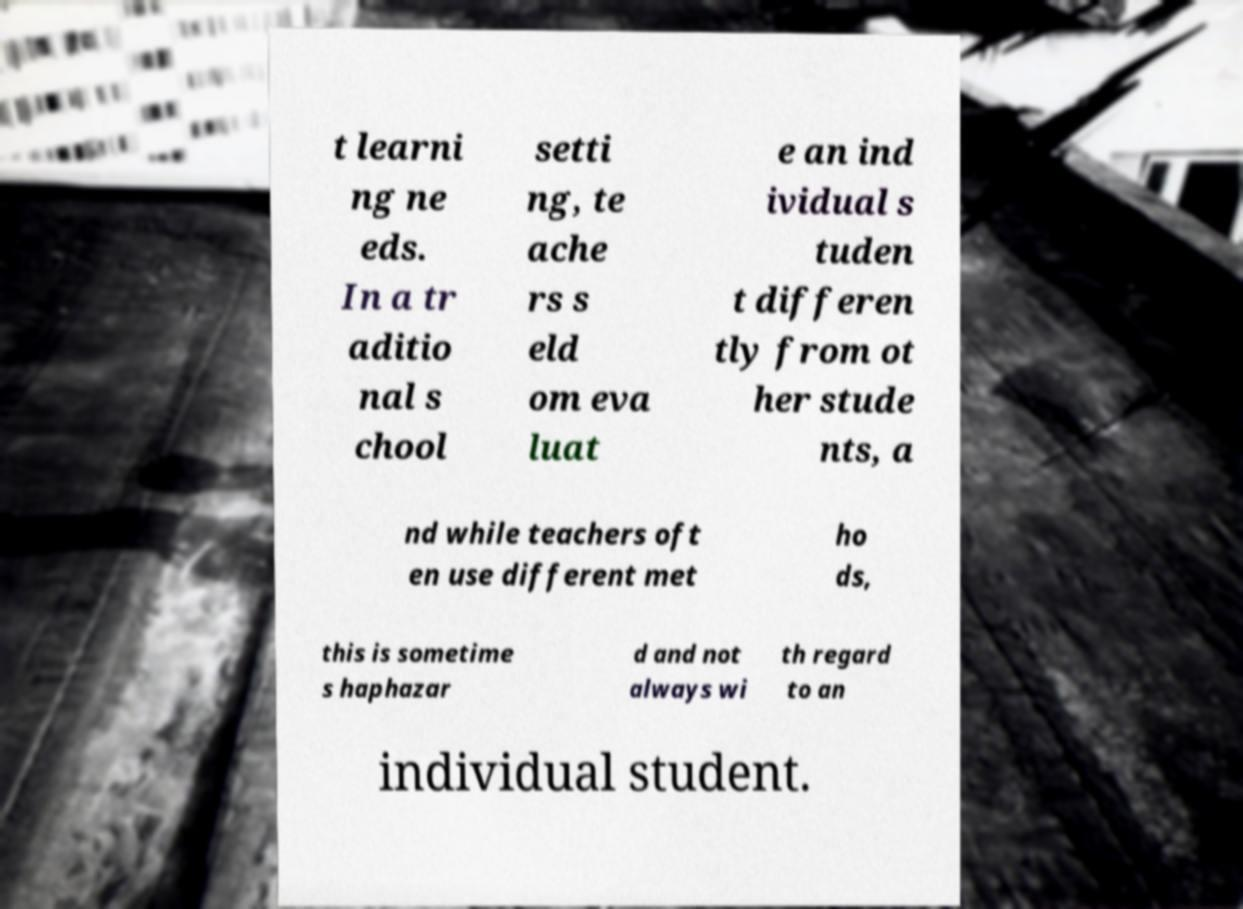Could you extract and type out the text from this image? t learni ng ne eds. In a tr aditio nal s chool setti ng, te ache rs s eld om eva luat e an ind ividual s tuden t differen tly from ot her stude nts, a nd while teachers oft en use different met ho ds, this is sometime s haphazar d and not always wi th regard to an individual student. 